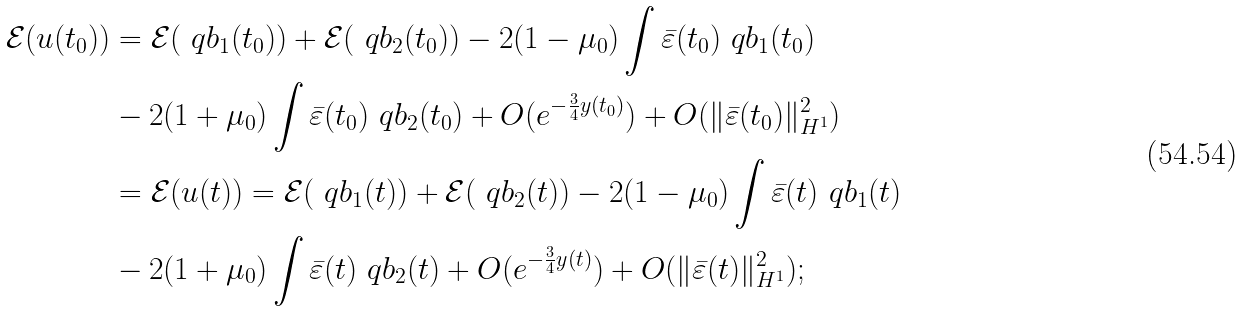<formula> <loc_0><loc_0><loc_500><loc_500>\mathcal { E } ( u ( t _ { 0 } ) ) & = \mathcal { E } ( \ q b _ { 1 } ( t _ { 0 } ) ) + \mathcal { E } ( \ q b _ { 2 } ( t _ { 0 } ) ) - 2 ( 1 - \mu _ { 0 } ) \int \bar { \varepsilon } ( t _ { 0 } ) \ q b _ { 1 } ( t _ { 0 } ) \\ & - 2 ( 1 + \mu _ { 0 } ) \int \bar { \varepsilon } ( t _ { 0 } ) \ q b _ { 2 } ( t _ { 0 } ) + O ( e ^ { - \frac { 3 } { 4 } y ( t _ { 0 } ) } ) + O ( \| \bar { \varepsilon } ( t _ { 0 } ) \| ^ { 2 } _ { H ^ { 1 } } ) \\ & = \mathcal { E } ( u ( t ) ) = \mathcal { E } ( \ q b _ { 1 } ( t ) ) + \mathcal { E } ( \ q b _ { 2 } ( t ) ) - 2 ( 1 - \mu _ { 0 } ) \int \bar { \varepsilon } ( t ) \ q b _ { 1 } ( t ) \\ & - 2 ( 1 + \mu _ { 0 } ) \int \bar { \varepsilon } ( t ) \ q b _ { 2 } ( t ) + O ( e ^ { - \frac { 3 } { 4 } y ( t ) } ) + O ( \| \bar { \varepsilon } ( t ) \| ^ { 2 } _ { H ^ { 1 } } ) ;</formula> 